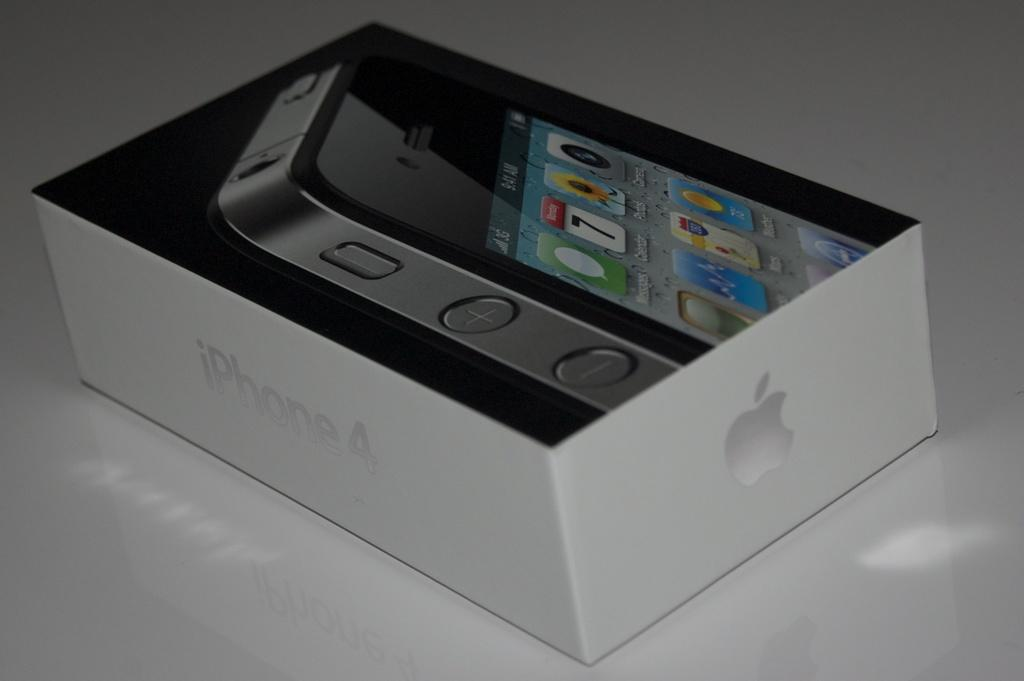<image>
Summarize the visual content of the image. An Iphone 4 is inside of a shiny box on a table. 